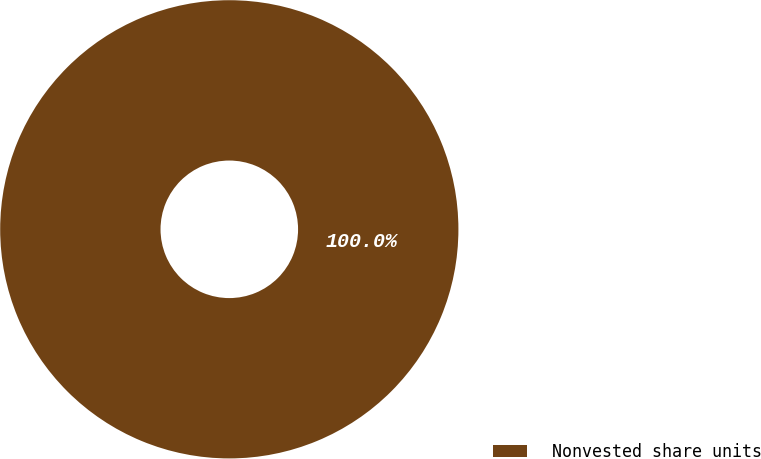Convert chart to OTSL. <chart><loc_0><loc_0><loc_500><loc_500><pie_chart><fcel>Nonvested share units<nl><fcel>100.0%<nl></chart> 